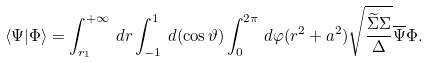Convert formula to latex. <formula><loc_0><loc_0><loc_500><loc_500>\langle \Psi | \Phi \rangle = \int _ { r _ { 1 } } ^ { + \infty } \, d r \int _ { - 1 } ^ { 1 } \, d ( \cos { \vartheta } ) \int _ { 0 } ^ { 2 \pi } \, d \varphi ( r ^ { 2 } + a ^ { 2 } ) \sqrt { \frac { \widetilde { \Sigma } \Sigma } { \Delta } } \overline { \Psi } \Phi .</formula> 